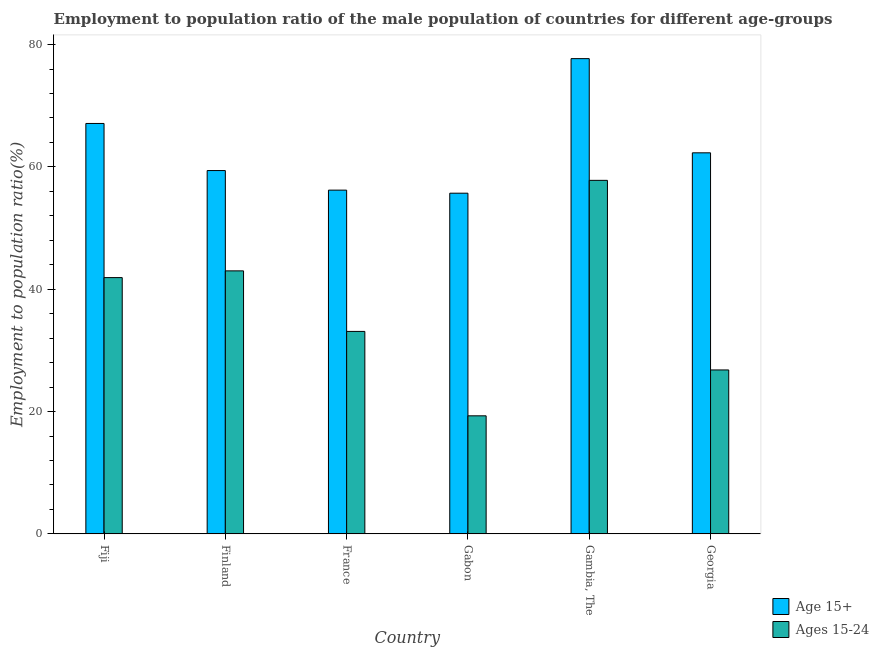Are the number of bars per tick equal to the number of legend labels?
Keep it short and to the point. Yes. Are the number of bars on each tick of the X-axis equal?
Your answer should be compact. Yes. How many bars are there on the 5th tick from the left?
Offer a terse response. 2. How many bars are there on the 1st tick from the right?
Ensure brevity in your answer.  2. What is the label of the 3rd group of bars from the left?
Make the answer very short. France. In how many cases, is the number of bars for a given country not equal to the number of legend labels?
Keep it short and to the point. 0. What is the employment to population ratio(age 15-24) in Gambia, The?
Offer a terse response. 57.8. Across all countries, what is the maximum employment to population ratio(age 15+)?
Your answer should be very brief. 77.7. Across all countries, what is the minimum employment to population ratio(age 15-24)?
Make the answer very short. 19.3. In which country was the employment to population ratio(age 15+) maximum?
Provide a short and direct response. Gambia, The. In which country was the employment to population ratio(age 15-24) minimum?
Give a very brief answer. Gabon. What is the total employment to population ratio(age 15-24) in the graph?
Give a very brief answer. 221.9. What is the difference between the employment to population ratio(age 15-24) in Finland and that in Gambia, The?
Your answer should be very brief. -14.8. What is the difference between the employment to population ratio(age 15-24) in Gambia, The and the employment to population ratio(age 15+) in Georgia?
Offer a very short reply. -4.5. What is the average employment to population ratio(age 15-24) per country?
Give a very brief answer. 36.98. What is the difference between the employment to population ratio(age 15-24) and employment to population ratio(age 15+) in Fiji?
Your answer should be very brief. -25.2. In how many countries, is the employment to population ratio(age 15+) greater than 16 %?
Keep it short and to the point. 6. What is the ratio of the employment to population ratio(age 15-24) in Gambia, The to that in Georgia?
Give a very brief answer. 2.16. Is the employment to population ratio(age 15+) in France less than that in Georgia?
Keep it short and to the point. Yes. What is the difference between the highest and the second highest employment to population ratio(age 15+)?
Give a very brief answer. 10.6. What is the difference between the highest and the lowest employment to population ratio(age 15+)?
Offer a terse response. 22. Is the sum of the employment to population ratio(age 15-24) in France and Georgia greater than the maximum employment to population ratio(age 15+) across all countries?
Keep it short and to the point. No. What does the 2nd bar from the left in Finland represents?
Provide a succinct answer. Ages 15-24. What does the 2nd bar from the right in Fiji represents?
Your response must be concise. Age 15+. Are all the bars in the graph horizontal?
Make the answer very short. No. How many countries are there in the graph?
Your answer should be very brief. 6. Does the graph contain any zero values?
Provide a succinct answer. No. Does the graph contain grids?
Your answer should be compact. No. Where does the legend appear in the graph?
Provide a succinct answer. Bottom right. How many legend labels are there?
Provide a succinct answer. 2. How are the legend labels stacked?
Provide a succinct answer. Vertical. What is the title of the graph?
Offer a very short reply. Employment to population ratio of the male population of countries for different age-groups. What is the label or title of the Y-axis?
Your response must be concise. Employment to population ratio(%). What is the Employment to population ratio(%) of Age 15+ in Fiji?
Your response must be concise. 67.1. What is the Employment to population ratio(%) of Ages 15-24 in Fiji?
Give a very brief answer. 41.9. What is the Employment to population ratio(%) in Age 15+ in Finland?
Offer a very short reply. 59.4. What is the Employment to population ratio(%) of Age 15+ in France?
Offer a terse response. 56.2. What is the Employment to population ratio(%) of Ages 15-24 in France?
Offer a very short reply. 33.1. What is the Employment to population ratio(%) of Age 15+ in Gabon?
Ensure brevity in your answer.  55.7. What is the Employment to population ratio(%) of Ages 15-24 in Gabon?
Your answer should be very brief. 19.3. What is the Employment to population ratio(%) in Age 15+ in Gambia, The?
Make the answer very short. 77.7. What is the Employment to population ratio(%) of Ages 15-24 in Gambia, The?
Your response must be concise. 57.8. What is the Employment to population ratio(%) of Age 15+ in Georgia?
Give a very brief answer. 62.3. What is the Employment to population ratio(%) of Ages 15-24 in Georgia?
Give a very brief answer. 26.8. Across all countries, what is the maximum Employment to population ratio(%) in Age 15+?
Provide a succinct answer. 77.7. Across all countries, what is the maximum Employment to population ratio(%) in Ages 15-24?
Your answer should be compact. 57.8. Across all countries, what is the minimum Employment to population ratio(%) of Age 15+?
Offer a very short reply. 55.7. Across all countries, what is the minimum Employment to population ratio(%) of Ages 15-24?
Provide a succinct answer. 19.3. What is the total Employment to population ratio(%) of Age 15+ in the graph?
Keep it short and to the point. 378.4. What is the total Employment to population ratio(%) of Ages 15-24 in the graph?
Your answer should be very brief. 221.9. What is the difference between the Employment to population ratio(%) in Age 15+ in Fiji and that in Finland?
Make the answer very short. 7.7. What is the difference between the Employment to population ratio(%) of Ages 15-24 in Fiji and that in Finland?
Ensure brevity in your answer.  -1.1. What is the difference between the Employment to population ratio(%) in Age 15+ in Fiji and that in France?
Make the answer very short. 10.9. What is the difference between the Employment to population ratio(%) of Ages 15-24 in Fiji and that in France?
Make the answer very short. 8.8. What is the difference between the Employment to population ratio(%) in Ages 15-24 in Fiji and that in Gabon?
Provide a succinct answer. 22.6. What is the difference between the Employment to population ratio(%) of Age 15+ in Fiji and that in Gambia, The?
Make the answer very short. -10.6. What is the difference between the Employment to population ratio(%) in Ages 15-24 in Fiji and that in Gambia, The?
Your answer should be compact. -15.9. What is the difference between the Employment to population ratio(%) of Ages 15-24 in Fiji and that in Georgia?
Give a very brief answer. 15.1. What is the difference between the Employment to population ratio(%) of Age 15+ in Finland and that in France?
Provide a succinct answer. 3.2. What is the difference between the Employment to population ratio(%) in Age 15+ in Finland and that in Gabon?
Provide a short and direct response. 3.7. What is the difference between the Employment to population ratio(%) in Ages 15-24 in Finland and that in Gabon?
Make the answer very short. 23.7. What is the difference between the Employment to population ratio(%) of Age 15+ in Finland and that in Gambia, The?
Your answer should be very brief. -18.3. What is the difference between the Employment to population ratio(%) of Ages 15-24 in Finland and that in Gambia, The?
Your response must be concise. -14.8. What is the difference between the Employment to population ratio(%) in Ages 15-24 in Finland and that in Georgia?
Your answer should be very brief. 16.2. What is the difference between the Employment to population ratio(%) of Age 15+ in France and that in Gabon?
Your answer should be very brief. 0.5. What is the difference between the Employment to population ratio(%) of Ages 15-24 in France and that in Gabon?
Provide a succinct answer. 13.8. What is the difference between the Employment to population ratio(%) of Age 15+ in France and that in Gambia, The?
Make the answer very short. -21.5. What is the difference between the Employment to population ratio(%) in Ages 15-24 in France and that in Gambia, The?
Your answer should be very brief. -24.7. What is the difference between the Employment to population ratio(%) of Ages 15-24 in Gabon and that in Gambia, The?
Make the answer very short. -38.5. What is the difference between the Employment to population ratio(%) of Age 15+ in Gabon and that in Georgia?
Offer a very short reply. -6.6. What is the difference between the Employment to population ratio(%) in Ages 15-24 in Gambia, The and that in Georgia?
Your response must be concise. 31. What is the difference between the Employment to population ratio(%) in Age 15+ in Fiji and the Employment to population ratio(%) in Ages 15-24 in Finland?
Provide a succinct answer. 24.1. What is the difference between the Employment to population ratio(%) in Age 15+ in Fiji and the Employment to population ratio(%) in Ages 15-24 in France?
Your answer should be very brief. 34. What is the difference between the Employment to population ratio(%) in Age 15+ in Fiji and the Employment to population ratio(%) in Ages 15-24 in Gabon?
Your answer should be compact. 47.8. What is the difference between the Employment to population ratio(%) of Age 15+ in Fiji and the Employment to population ratio(%) of Ages 15-24 in Georgia?
Provide a succinct answer. 40.3. What is the difference between the Employment to population ratio(%) in Age 15+ in Finland and the Employment to population ratio(%) in Ages 15-24 in France?
Your response must be concise. 26.3. What is the difference between the Employment to population ratio(%) of Age 15+ in Finland and the Employment to population ratio(%) of Ages 15-24 in Gabon?
Your answer should be compact. 40.1. What is the difference between the Employment to population ratio(%) in Age 15+ in Finland and the Employment to population ratio(%) in Ages 15-24 in Gambia, The?
Offer a terse response. 1.6. What is the difference between the Employment to population ratio(%) of Age 15+ in Finland and the Employment to population ratio(%) of Ages 15-24 in Georgia?
Offer a very short reply. 32.6. What is the difference between the Employment to population ratio(%) of Age 15+ in France and the Employment to population ratio(%) of Ages 15-24 in Gabon?
Your answer should be compact. 36.9. What is the difference between the Employment to population ratio(%) in Age 15+ in France and the Employment to population ratio(%) in Ages 15-24 in Gambia, The?
Make the answer very short. -1.6. What is the difference between the Employment to population ratio(%) in Age 15+ in France and the Employment to population ratio(%) in Ages 15-24 in Georgia?
Ensure brevity in your answer.  29.4. What is the difference between the Employment to population ratio(%) in Age 15+ in Gabon and the Employment to population ratio(%) in Ages 15-24 in Georgia?
Ensure brevity in your answer.  28.9. What is the difference between the Employment to population ratio(%) of Age 15+ in Gambia, The and the Employment to population ratio(%) of Ages 15-24 in Georgia?
Provide a short and direct response. 50.9. What is the average Employment to population ratio(%) of Age 15+ per country?
Provide a short and direct response. 63.07. What is the average Employment to population ratio(%) in Ages 15-24 per country?
Your answer should be compact. 36.98. What is the difference between the Employment to population ratio(%) of Age 15+ and Employment to population ratio(%) of Ages 15-24 in Fiji?
Give a very brief answer. 25.2. What is the difference between the Employment to population ratio(%) of Age 15+ and Employment to population ratio(%) of Ages 15-24 in France?
Offer a very short reply. 23.1. What is the difference between the Employment to population ratio(%) of Age 15+ and Employment to population ratio(%) of Ages 15-24 in Gabon?
Keep it short and to the point. 36.4. What is the difference between the Employment to population ratio(%) in Age 15+ and Employment to population ratio(%) in Ages 15-24 in Georgia?
Your answer should be compact. 35.5. What is the ratio of the Employment to population ratio(%) of Age 15+ in Fiji to that in Finland?
Ensure brevity in your answer.  1.13. What is the ratio of the Employment to population ratio(%) of Ages 15-24 in Fiji to that in Finland?
Ensure brevity in your answer.  0.97. What is the ratio of the Employment to population ratio(%) in Age 15+ in Fiji to that in France?
Your answer should be very brief. 1.19. What is the ratio of the Employment to population ratio(%) in Ages 15-24 in Fiji to that in France?
Give a very brief answer. 1.27. What is the ratio of the Employment to population ratio(%) in Age 15+ in Fiji to that in Gabon?
Offer a terse response. 1.2. What is the ratio of the Employment to population ratio(%) of Ages 15-24 in Fiji to that in Gabon?
Offer a terse response. 2.17. What is the ratio of the Employment to population ratio(%) of Age 15+ in Fiji to that in Gambia, The?
Your response must be concise. 0.86. What is the ratio of the Employment to population ratio(%) in Ages 15-24 in Fiji to that in Gambia, The?
Give a very brief answer. 0.72. What is the ratio of the Employment to population ratio(%) in Age 15+ in Fiji to that in Georgia?
Offer a very short reply. 1.08. What is the ratio of the Employment to population ratio(%) of Ages 15-24 in Fiji to that in Georgia?
Keep it short and to the point. 1.56. What is the ratio of the Employment to population ratio(%) of Age 15+ in Finland to that in France?
Your answer should be very brief. 1.06. What is the ratio of the Employment to population ratio(%) in Ages 15-24 in Finland to that in France?
Provide a short and direct response. 1.3. What is the ratio of the Employment to population ratio(%) in Age 15+ in Finland to that in Gabon?
Offer a very short reply. 1.07. What is the ratio of the Employment to population ratio(%) in Ages 15-24 in Finland to that in Gabon?
Give a very brief answer. 2.23. What is the ratio of the Employment to population ratio(%) of Age 15+ in Finland to that in Gambia, The?
Ensure brevity in your answer.  0.76. What is the ratio of the Employment to population ratio(%) of Ages 15-24 in Finland to that in Gambia, The?
Your response must be concise. 0.74. What is the ratio of the Employment to population ratio(%) of Age 15+ in Finland to that in Georgia?
Your response must be concise. 0.95. What is the ratio of the Employment to population ratio(%) in Ages 15-24 in Finland to that in Georgia?
Your response must be concise. 1.6. What is the ratio of the Employment to population ratio(%) of Age 15+ in France to that in Gabon?
Ensure brevity in your answer.  1.01. What is the ratio of the Employment to population ratio(%) of Ages 15-24 in France to that in Gabon?
Provide a succinct answer. 1.72. What is the ratio of the Employment to population ratio(%) in Age 15+ in France to that in Gambia, The?
Give a very brief answer. 0.72. What is the ratio of the Employment to population ratio(%) of Ages 15-24 in France to that in Gambia, The?
Offer a very short reply. 0.57. What is the ratio of the Employment to population ratio(%) of Age 15+ in France to that in Georgia?
Ensure brevity in your answer.  0.9. What is the ratio of the Employment to population ratio(%) in Ages 15-24 in France to that in Georgia?
Ensure brevity in your answer.  1.24. What is the ratio of the Employment to population ratio(%) of Age 15+ in Gabon to that in Gambia, The?
Keep it short and to the point. 0.72. What is the ratio of the Employment to population ratio(%) of Ages 15-24 in Gabon to that in Gambia, The?
Your answer should be very brief. 0.33. What is the ratio of the Employment to population ratio(%) in Age 15+ in Gabon to that in Georgia?
Make the answer very short. 0.89. What is the ratio of the Employment to population ratio(%) in Ages 15-24 in Gabon to that in Georgia?
Offer a very short reply. 0.72. What is the ratio of the Employment to population ratio(%) of Age 15+ in Gambia, The to that in Georgia?
Provide a short and direct response. 1.25. What is the ratio of the Employment to population ratio(%) of Ages 15-24 in Gambia, The to that in Georgia?
Provide a short and direct response. 2.16. What is the difference between the highest and the second highest Employment to population ratio(%) of Age 15+?
Ensure brevity in your answer.  10.6. What is the difference between the highest and the lowest Employment to population ratio(%) of Ages 15-24?
Offer a very short reply. 38.5. 